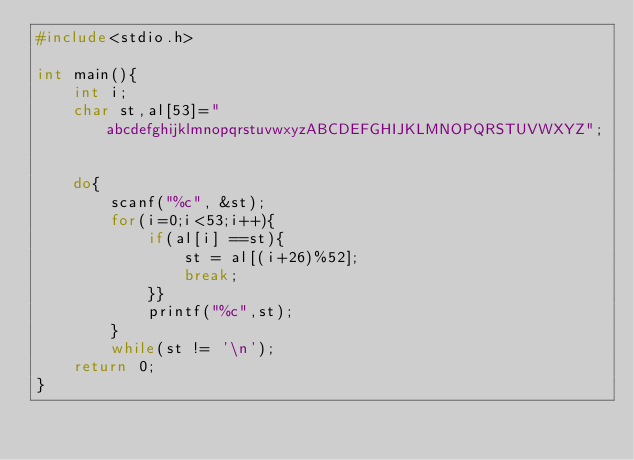<code> <loc_0><loc_0><loc_500><loc_500><_C_>#include<stdio.h>

int main(){
    int i;
    char st,al[53]="abcdefghijklmnopqrstuvwxyzABCDEFGHIJKLMNOPQRSTUVWXYZ";
    
    
    do{
        scanf("%c", &st);
        for(i=0;i<53;i++){
            if(al[i] ==st){
                st = al[(i+26)%52];
                break;
            }}
            printf("%c",st);
        }
        while(st != '\n');
    return 0;
}

</code> 